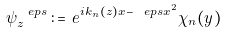<formula> <loc_0><loc_0><loc_500><loc_500>\psi _ { z } ^ { \ e p s } \, \colon = \, e ^ { i k _ { n } ( z ) x - \ e p s x ^ { 2 } } \chi _ { n } ( y )</formula> 